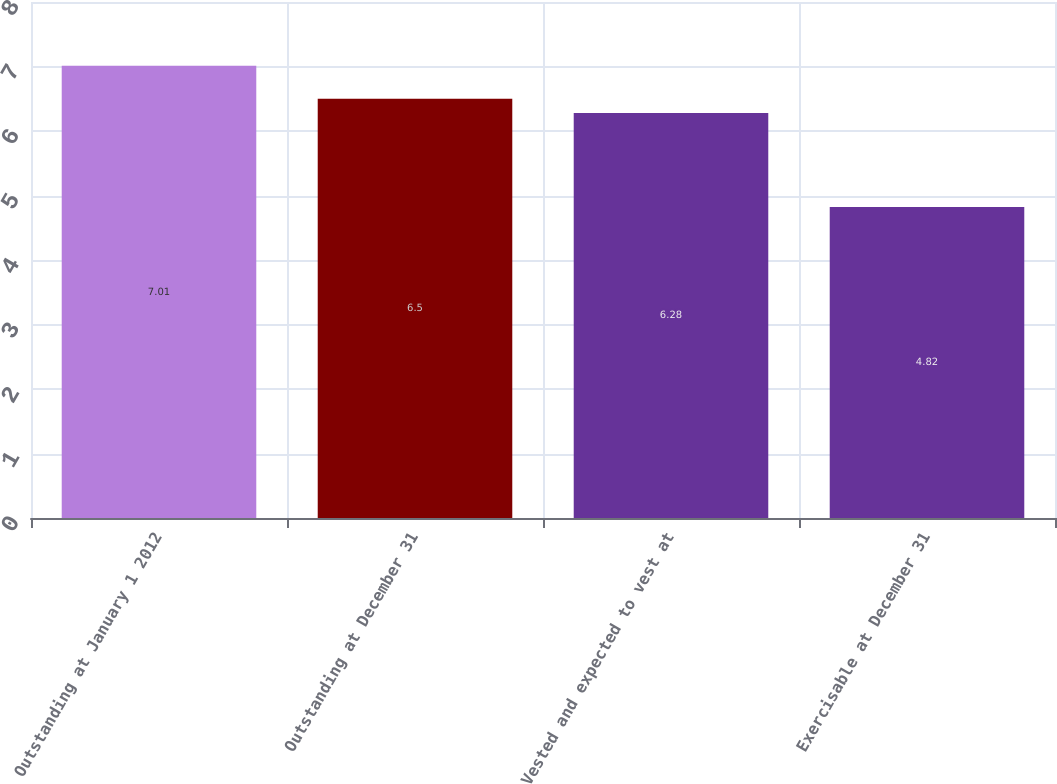Convert chart. <chart><loc_0><loc_0><loc_500><loc_500><bar_chart><fcel>Outstanding at January 1 2012<fcel>Outstanding at December 31<fcel>Vested and expected to vest at<fcel>Exercisable at December 31<nl><fcel>7.01<fcel>6.5<fcel>6.28<fcel>4.82<nl></chart> 